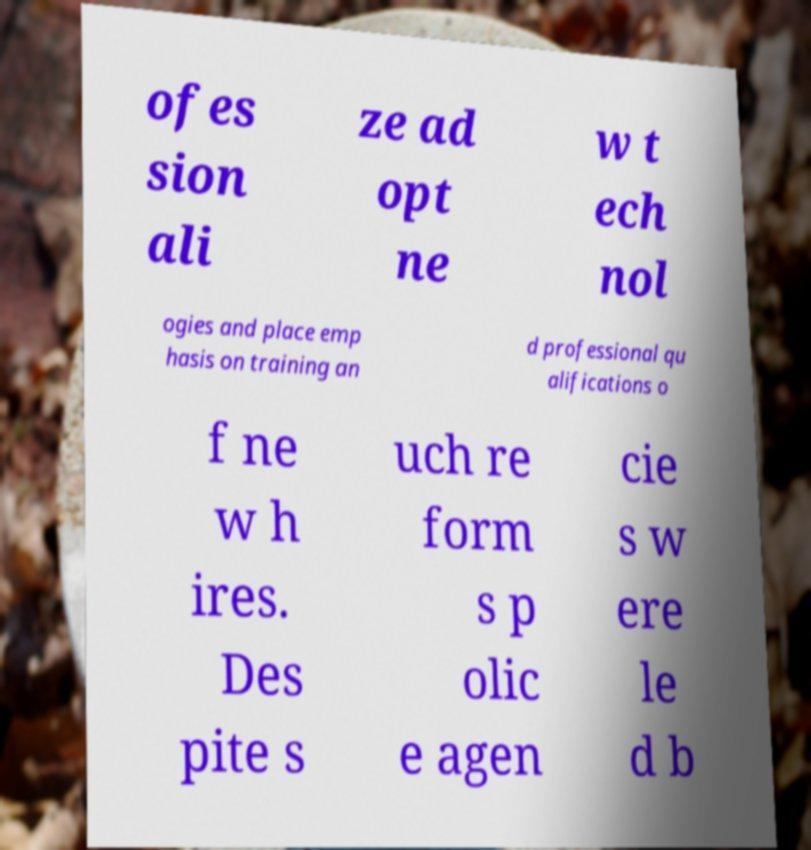Can you read and provide the text displayed in the image?This photo seems to have some interesting text. Can you extract and type it out for me? ofes sion ali ze ad opt ne w t ech nol ogies and place emp hasis on training an d professional qu alifications o f ne w h ires. Des pite s uch re form s p olic e agen cie s w ere le d b 